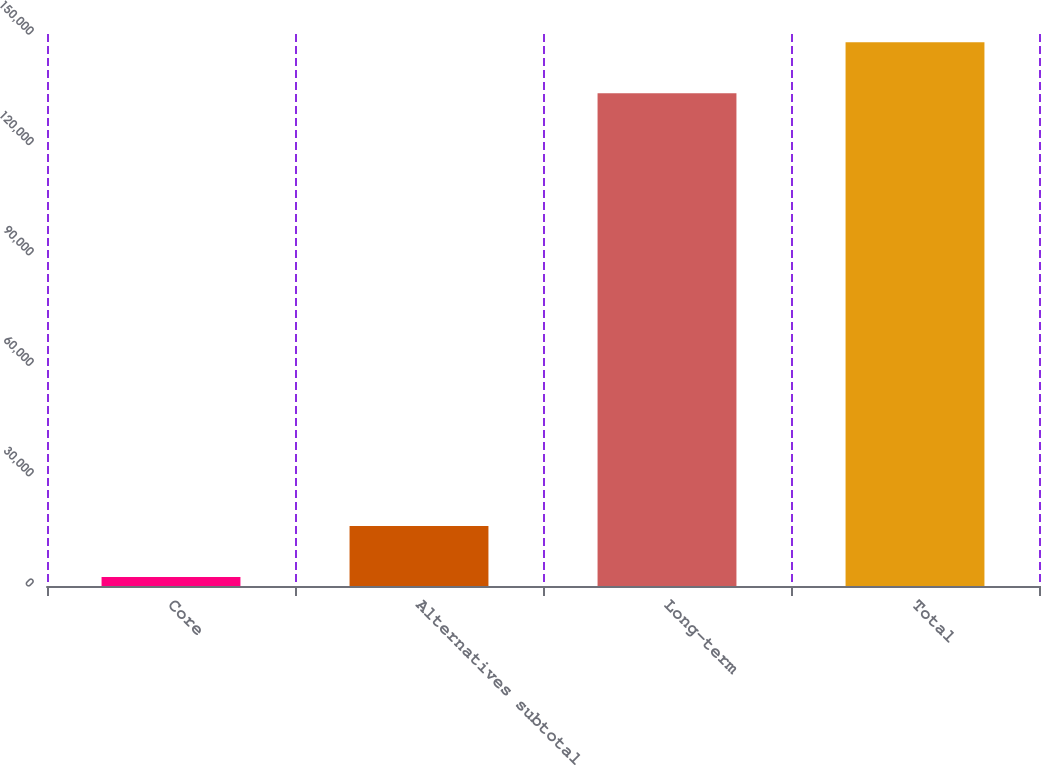Convert chart. <chart><loc_0><loc_0><loc_500><loc_500><bar_chart><fcel>Core<fcel>Alternatives subtotal<fcel>Long-term<fcel>Total<nl><fcel>2421<fcel>16271.3<fcel>133874<fcel>147724<nl></chart> 